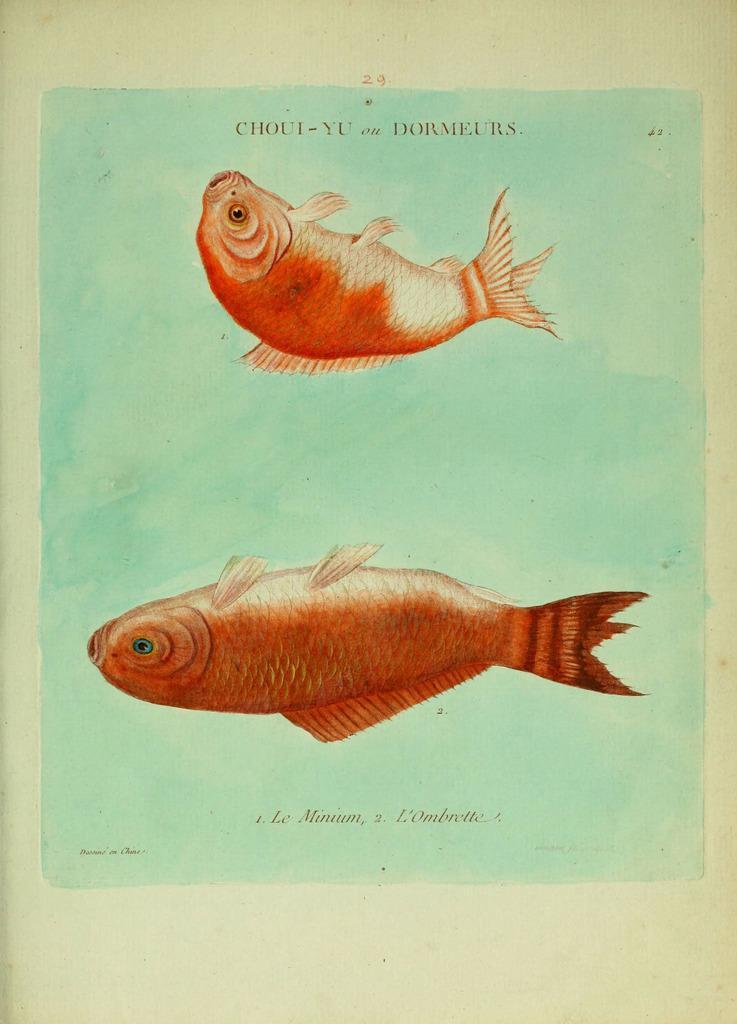Describe this image in one or two sentences. In the image we can see a paper, on the paper there are fish paintings. 